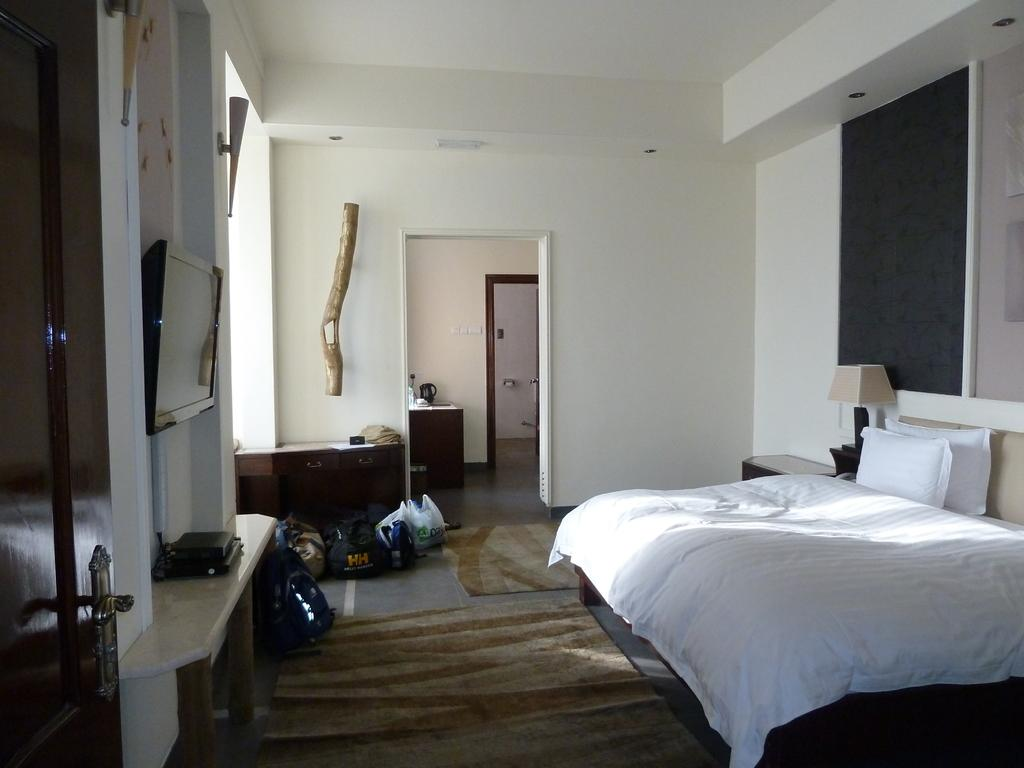Where is the image taken? The image is taken inside a room. What can be seen on the right side of the room? There is a lamp and a bed on the right side of the room. What is in the center of the room? There is a floor mat in the center of the room. What is on the left side wall of the room? There is a TV on the left side wall of the room. What type of haircut is the fan giving in the image? There is no fan or haircut present in the image. 